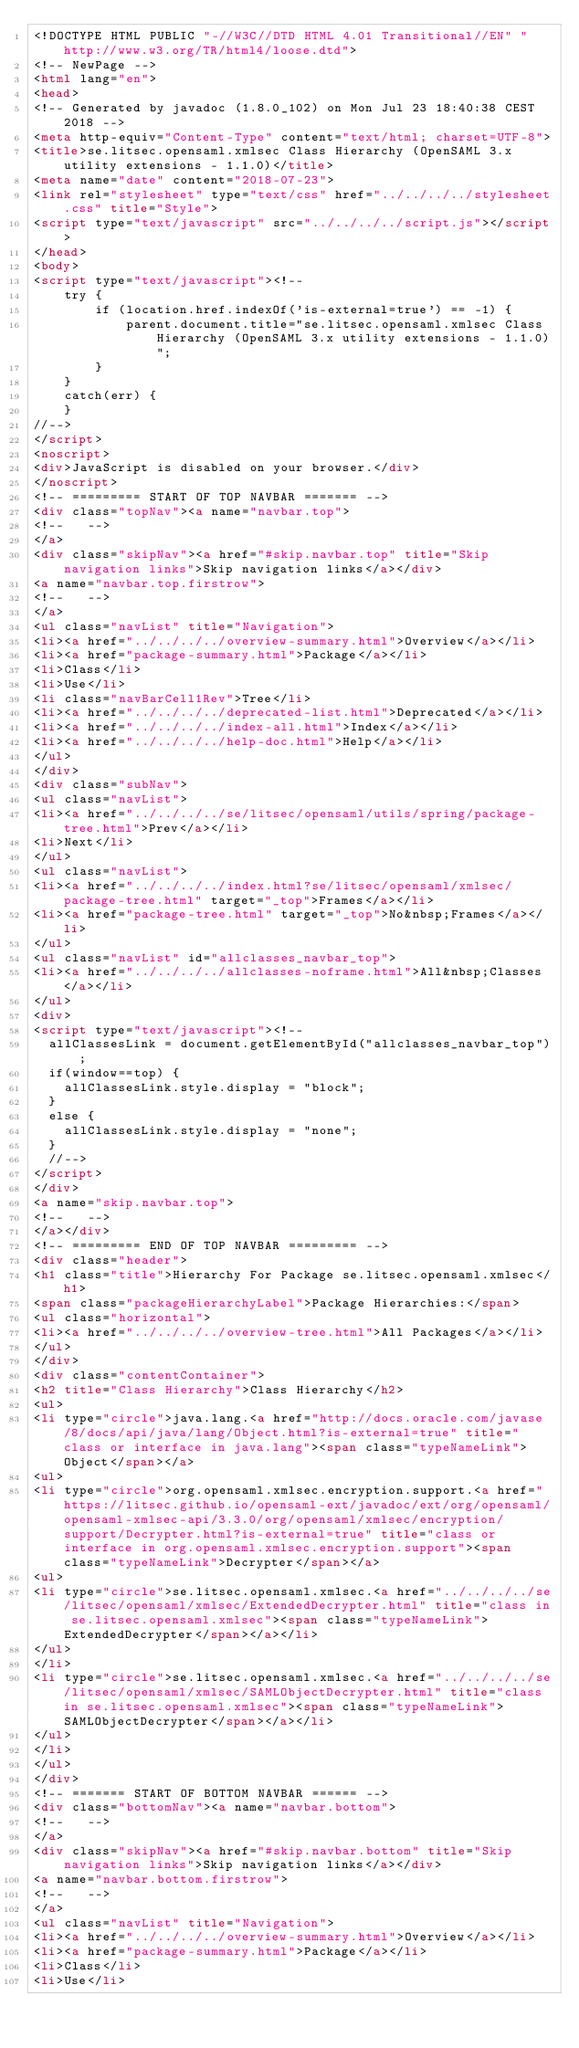<code> <loc_0><loc_0><loc_500><loc_500><_HTML_><!DOCTYPE HTML PUBLIC "-//W3C//DTD HTML 4.01 Transitional//EN" "http://www.w3.org/TR/html4/loose.dtd">
<!-- NewPage -->
<html lang="en">
<head>
<!-- Generated by javadoc (1.8.0_102) on Mon Jul 23 18:40:38 CEST 2018 -->
<meta http-equiv="Content-Type" content="text/html; charset=UTF-8">
<title>se.litsec.opensaml.xmlsec Class Hierarchy (OpenSAML 3.x utility extensions - 1.1.0)</title>
<meta name="date" content="2018-07-23">
<link rel="stylesheet" type="text/css" href="../../../../stylesheet.css" title="Style">
<script type="text/javascript" src="../../../../script.js"></script>
</head>
<body>
<script type="text/javascript"><!--
    try {
        if (location.href.indexOf('is-external=true') == -1) {
            parent.document.title="se.litsec.opensaml.xmlsec Class Hierarchy (OpenSAML 3.x utility extensions - 1.1.0)";
        }
    }
    catch(err) {
    }
//-->
</script>
<noscript>
<div>JavaScript is disabled on your browser.</div>
</noscript>
<!-- ========= START OF TOP NAVBAR ======= -->
<div class="topNav"><a name="navbar.top">
<!--   -->
</a>
<div class="skipNav"><a href="#skip.navbar.top" title="Skip navigation links">Skip navigation links</a></div>
<a name="navbar.top.firstrow">
<!--   -->
</a>
<ul class="navList" title="Navigation">
<li><a href="../../../../overview-summary.html">Overview</a></li>
<li><a href="package-summary.html">Package</a></li>
<li>Class</li>
<li>Use</li>
<li class="navBarCell1Rev">Tree</li>
<li><a href="../../../../deprecated-list.html">Deprecated</a></li>
<li><a href="../../../../index-all.html">Index</a></li>
<li><a href="../../../../help-doc.html">Help</a></li>
</ul>
</div>
<div class="subNav">
<ul class="navList">
<li><a href="../../../../se/litsec/opensaml/utils/spring/package-tree.html">Prev</a></li>
<li>Next</li>
</ul>
<ul class="navList">
<li><a href="../../../../index.html?se/litsec/opensaml/xmlsec/package-tree.html" target="_top">Frames</a></li>
<li><a href="package-tree.html" target="_top">No&nbsp;Frames</a></li>
</ul>
<ul class="navList" id="allclasses_navbar_top">
<li><a href="../../../../allclasses-noframe.html">All&nbsp;Classes</a></li>
</ul>
<div>
<script type="text/javascript"><!--
  allClassesLink = document.getElementById("allclasses_navbar_top");
  if(window==top) {
    allClassesLink.style.display = "block";
  }
  else {
    allClassesLink.style.display = "none";
  }
  //-->
</script>
</div>
<a name="skip.navbar.top">
<!--   -->
</a></div>
<!-- ========= END OF TOP NAVBAR ========= -->
<div class="header">
<h1 class="title">Hierarchy For Package se.litsec.opensaml.xmlsec</h1>
<span class="packageHierarchyLabel">Package Hierarchies:</span>
<ul class="horizontal">
<li><a href="../../../../overview-tree.html">All Packages</a></li>
</ul>
</div>
<div class="contentContainer">
<h2 title="Class Hierarchy">Class Hierarchy</h2>
<ul>
<li type="circle">java.lang.<a href="http://docs.oracle.com/javase/8/docs/api/java/lang/Object.html?is-external=true" title="class or interface in java.lang"><span class="typeNameLink">Object</span></a>
<ul>
<li type="circle">org.opensaml.xmlsec.encryption.support.<a href="https://litsec.github.io/opensaml-ext/javadoc/ext/org/opensaml/opensaml-xmlsec-api/3.3.0/org/opensaml/xmlsec/encryption/support/Decrypter.html?is-external=true" title="class or interface in org.opensaml.xmlsec.encryption.support"><span class="typeNameLink">Decrypter</span></a>
<ul>
<li type="circle">se.litsec.opensaml.xmlsec.<a href="../../../../se/litsec/opensaml/xmlsec/ExtendedDecrypter.html" title="class in se.litsec.opensaml.xmlsec"><span class="typeNameLink">ExtendedDecrypter</span></a></li>
</ul>
</li>
<li type="circle">se.litsec.opensaml.xmlsec.<a href="../../../../se/litsec/opensaml/xmlsec/SAMLObjectDecrypter.html" title="class in se.litsec.opensaml.xmlsec"><span class="typeNameLink">SAMLObjectDecrypter</span></a></li>
</ul>
</li>
</ul>
</div>
<!-- ======= START OF BOTTOM NAVBAR ====== -->
<div class="bottomNav"><a name="navbar.bottom">
<!--   -->
</a>
<div class="skipNav"><a href="#skip.navbar.bottom" title="Skip navigation links">Skip navigation links</a></div>
<a name="navbar.bottom.firstrow">
<!--   -->
</a>
<ul class="navList" title="Navigation">
<li><a href="../../../../overview-summary.html">Overview</a></li>
<li><a href="package-summary.html">Package</a></li>
<li>Class</li>
<li>Use</li></code> 